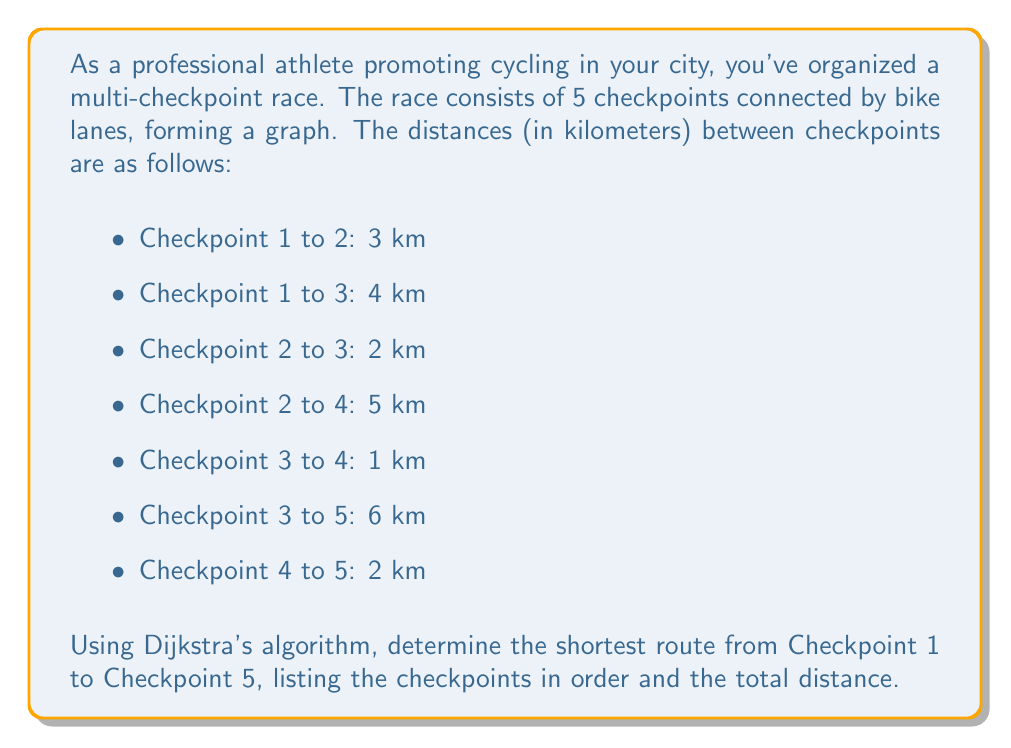Teach me how to tackle this problem. To solve this problem, we'll use Dijkstra's algorithm to find the shortest path from Checkpoint 1 to Checkpoint 5. Let's follow these steps:

1) First, let's represent the graph:

[asy]
unitsize(1cm);

pair[] vertices = {(0,0), (3,2), (3,-2), (6,2), (9,0)};
string[] labels = {"1", "2", "3", "4", "5"};

for(int i = 0; i < 5; ++i) {
  dot(vertices[i]);
  label(labels[i], vertices[i], align=E);
}

draw(vertices[0]--vertices[1], arrow=Arrow(TeXHead), L="3");
draw(vertices[0]--vertices[2], arrow=Arrow(TeXHead), L="4");
draw(vertices[1]--vertices[2], arrow=Arrow(TeXHead), L="2");
draw(vertices[1]--vertices[3], arrow=Arrow(TeXHead), L="5");
draw(vertices[2]--vertices[3], arrow=Arrow(TeXHead), L="1");
draw(vertices[2]--vertices[4], arrow=Arrow(TeXHead), L="6");
draw(vertices[3]--vertices[4], arrow=Arrow(TeXHead), L="2");
[/asy]

2) Initialize:
   - Distance to Checkpoint 1: 0
   - Distance to all other checkpoints: $\infty$
   - Set of unvisited nodes: {1, 2, 3, 4, 5}

3) Start from Checkpoint 1:
   - Update distances: 
     Checkpoint 2: min($\infty$, 0 + 3) = 3
     Checkpoint 3: min($\infty$, 0 + 4) = 4
   - Mark Checkpoint 1 as visited

4) Choose the checkpoint with the smallest distance (Checkpoint 2):
   - Update distances:
     Checkpoint 3: min(4, 3 + 2) = 4 (no change)
     Checkpoint 4: min($\infty$, 3 + 5) = 8
   - Mark Checkpoint 2 as visited

5) Choose the next smallest (Checkpoint 3):
   - Update distances:
     Checkpoint 4: min(8, 4 + 1) = 5
     Checkpoint 5: min($\infty$, 4 + 6) = 10
   - Mark Checkpoint 3 as visited

6) Choose Checkpoint 4:
   - Update distances:
     Checkpoint 5: min(10, 5 + 2) = 7
   - Mark Checkpoint 4 as visited

7) Finally, visit Checkpoint 5

The shortest path is: 1 → 3 → 4 → 5
The total distance is 7 km.
Answer: The shortest route from Checkpoint 1 to Checkpoint 5 is: 1 → 3 → 4 → 5, with a total distance of 7 km. 